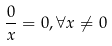<formula> <loc_0><loc_0><loc_500><loc_500>\frac { 0 } { x } = 0 , \forall x \ne 0</formula> 